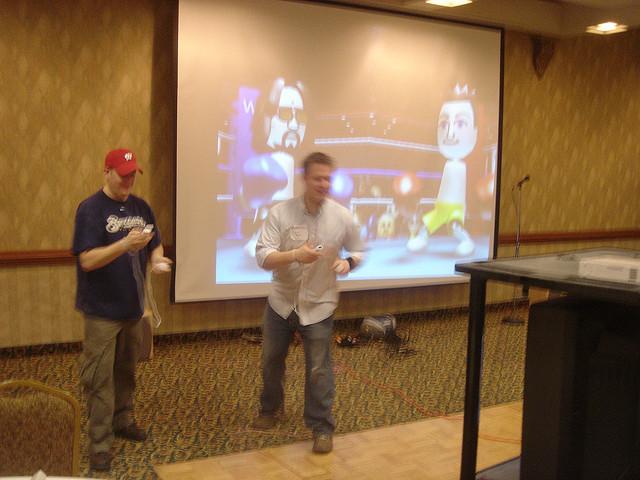What type of game are they playing?
Quick response, please. Boxing. Are the people facing the screen?
Answer briefly. No. What trick is being performed?
Answer briefly. 0. What are these men doing?
Short answer required. Playing wii. Which man is wearing a Red Hat?
Short answer required. On left. 